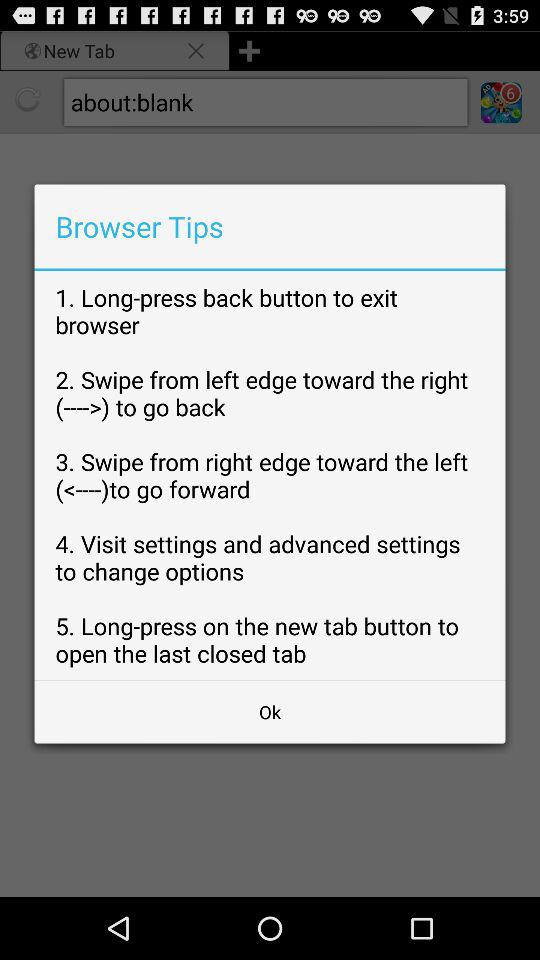How many tips are there that involve swiping?
Answer the question using a single word or phrase. 2 